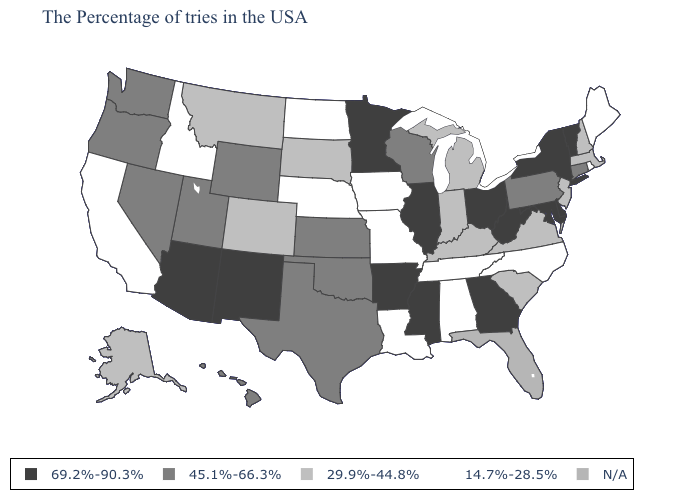Does Arizona have the highest value in the West?
Quick response, please. Yes. Which states have the highest value in the USA?
Short answer required. Vermont, New York, Delaware, Maryland, West Virginia, Ohio, Georgia, Illinois, Mississippi, Arkansas, Minnesota, New Mexico, Arizona. What is the value of Georgia?
Give a very brief answer. 69.2%-90.3%. Among the states that border Kansas , which have the highest value?
Keep it brief. Oklahoma. What is the value of South Carolina?
Answer briefly. 29.9%-44.8%. Name the states that have a value in the range 69.2%-90.3%?
Quick response, please. Vermont, New York, Delaware, Maryland, West Virginia, Ohio, Georgia, Illinois, Mississippi, Arkansas, Minnesota, New Mexico, Arizona. Which states have the lowest value in the USA?
Keep it brief. Maine, Rhode Island, North Carolina, Alabama, Tennessee, Louisiana, Missouri, Iowa, Nebraska, North Dakota, Idaho, California. Which states have the lowest value in the West?
Keep it brief. Idaho, California. Does Missouri have the lowest value in the MidWest?
Short answer required. Yes. Name the states that have a value in the range 29.9%-44.8%?
Quick response, please. Massachusetts, New Hampshire, New Jersey, Virginia, South Carolina, Michigan, Kentucky, Indiana, South Dakota, Colorado, Montana, Alaska. Name the states that have a value in the range 69.2%-90.3%?
Short answer required. Vermont, New York, Delaware, Maryland, West Virginia, Ohio, Georgia, Illinois, Mississippi, Arkansas, Minnesota, New Mexico, Arizona. What is the value of West Virginia?
Be succinct. 69.2%-90.3%. Among the states that border Mississippi , does Louisiana have the lowest value?
Quick response, please. Yes. Name the states that have a value in the range 29.9%-44.8%?
Answer briefly. Massachusetts, New Hampshire, New Jersey, Virginia, South Carolina, Michigan, Kentucky, Indiana, South Dakota, Colorado, Montana, Alaska. 